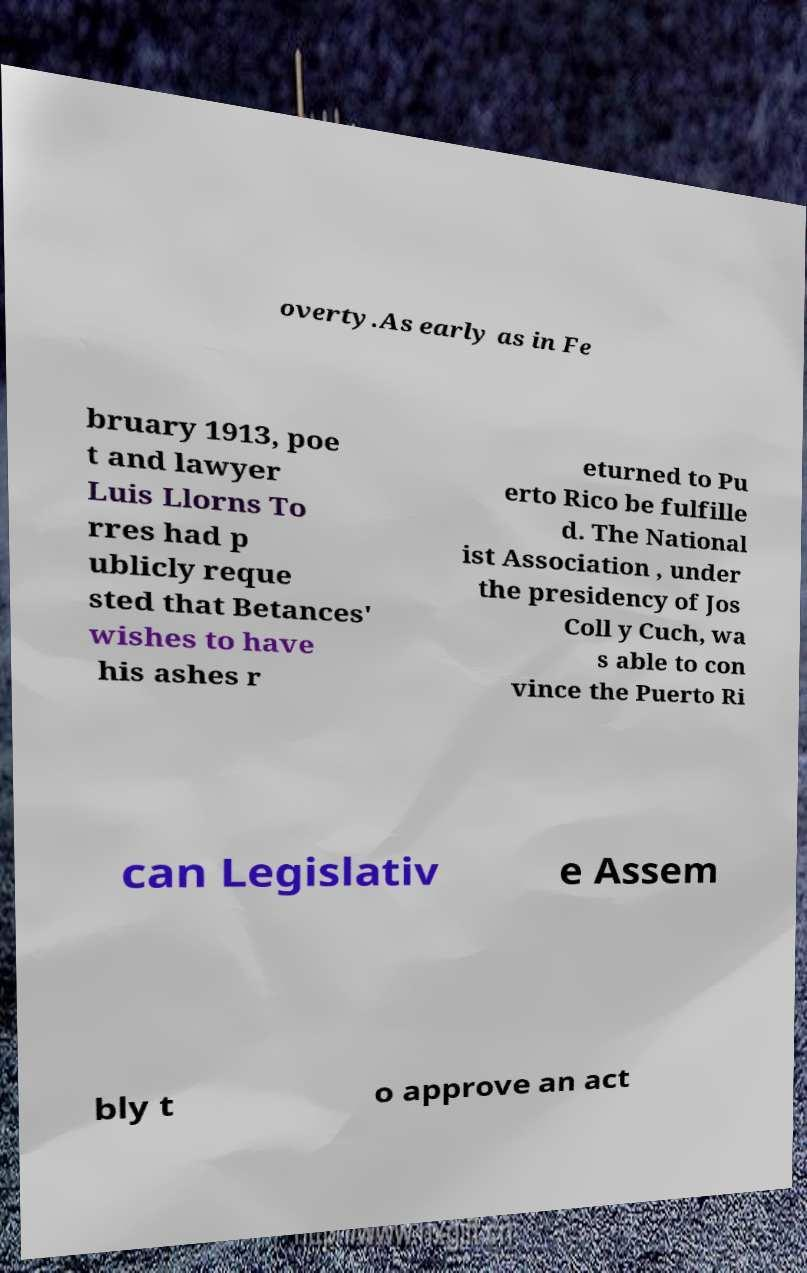There's text embedded in this image that I need extracted. Can you transcribe it verbatim? overty.As early as in Fe bruary 1913, poe t and lawyer Luis Llorns To rres had p ublicly reque sted that Betances' wishes to have his ashes r eturned to Pu erto Rico be fulfille d. The National ist Association , under the presidency of Jos Coll y Cuch, wa s able to con vince the Puerto Ri can Legislativ e Assem bly t o approve an act 